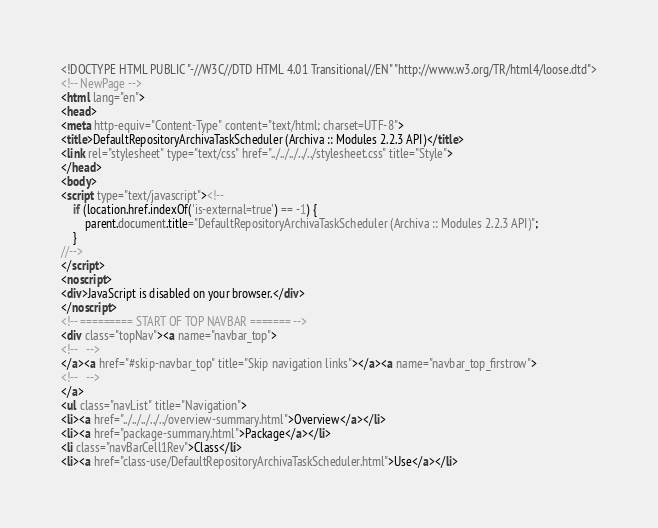<code> <loc_0><loc_0><loc_500><loc_500><_HTML_><!DOCTYPE HTML PUBLIC "-//W3C//DTD HTML 4.01 Transitional//EN" "http://www.w3.org/TR/html4/loose.dtd">
<!-- NewPage -->
<html lang="en">
<head>
<meta http-equiv="Content-Type" content="text/html; charset=UTF-8">
<title>DefaultRepositoryArchivaTaskScheduler (Archiva :: Modules 2.2.3 API)</title>
<link rel="stylesheet" type="text/css" href="../../../../../stylesheet.css" title="Style">
</head>
<body>
<script type="text/javascript"><!--
    if (location.href.indexOf('is-external=true') == -1) {
        parent.document.title="DefaultRepositoryArchivaTaskScheduler (Archiva :: Modules 2.2.3 API)";
    }
//-->
</script>
<noscript>
<div>JavaScript is disabled on your browser.</div>
</noscript>
<!-- ========= START OF TOP NAVBAR ======= -->
<div class="topNav"><a name="navbar_top">
<!--   -->
</a><a href="#skip-navbar_top" title="Skip navigation links"></a><a name="navbar_top_firstrow">
<!--   -->
</a>
<ul class="navList" title="Navigation">
<li><a href="../../../../../overview-summary.html">Overview</a></li>
<li><a href="package-summary.html">Package</a></li>
<li class="navBarCell1Rev">Class</li>
<li><a href="class-use/DefaultRepositoryArchivaTaskScheduler.html">Use</a></li></code> 